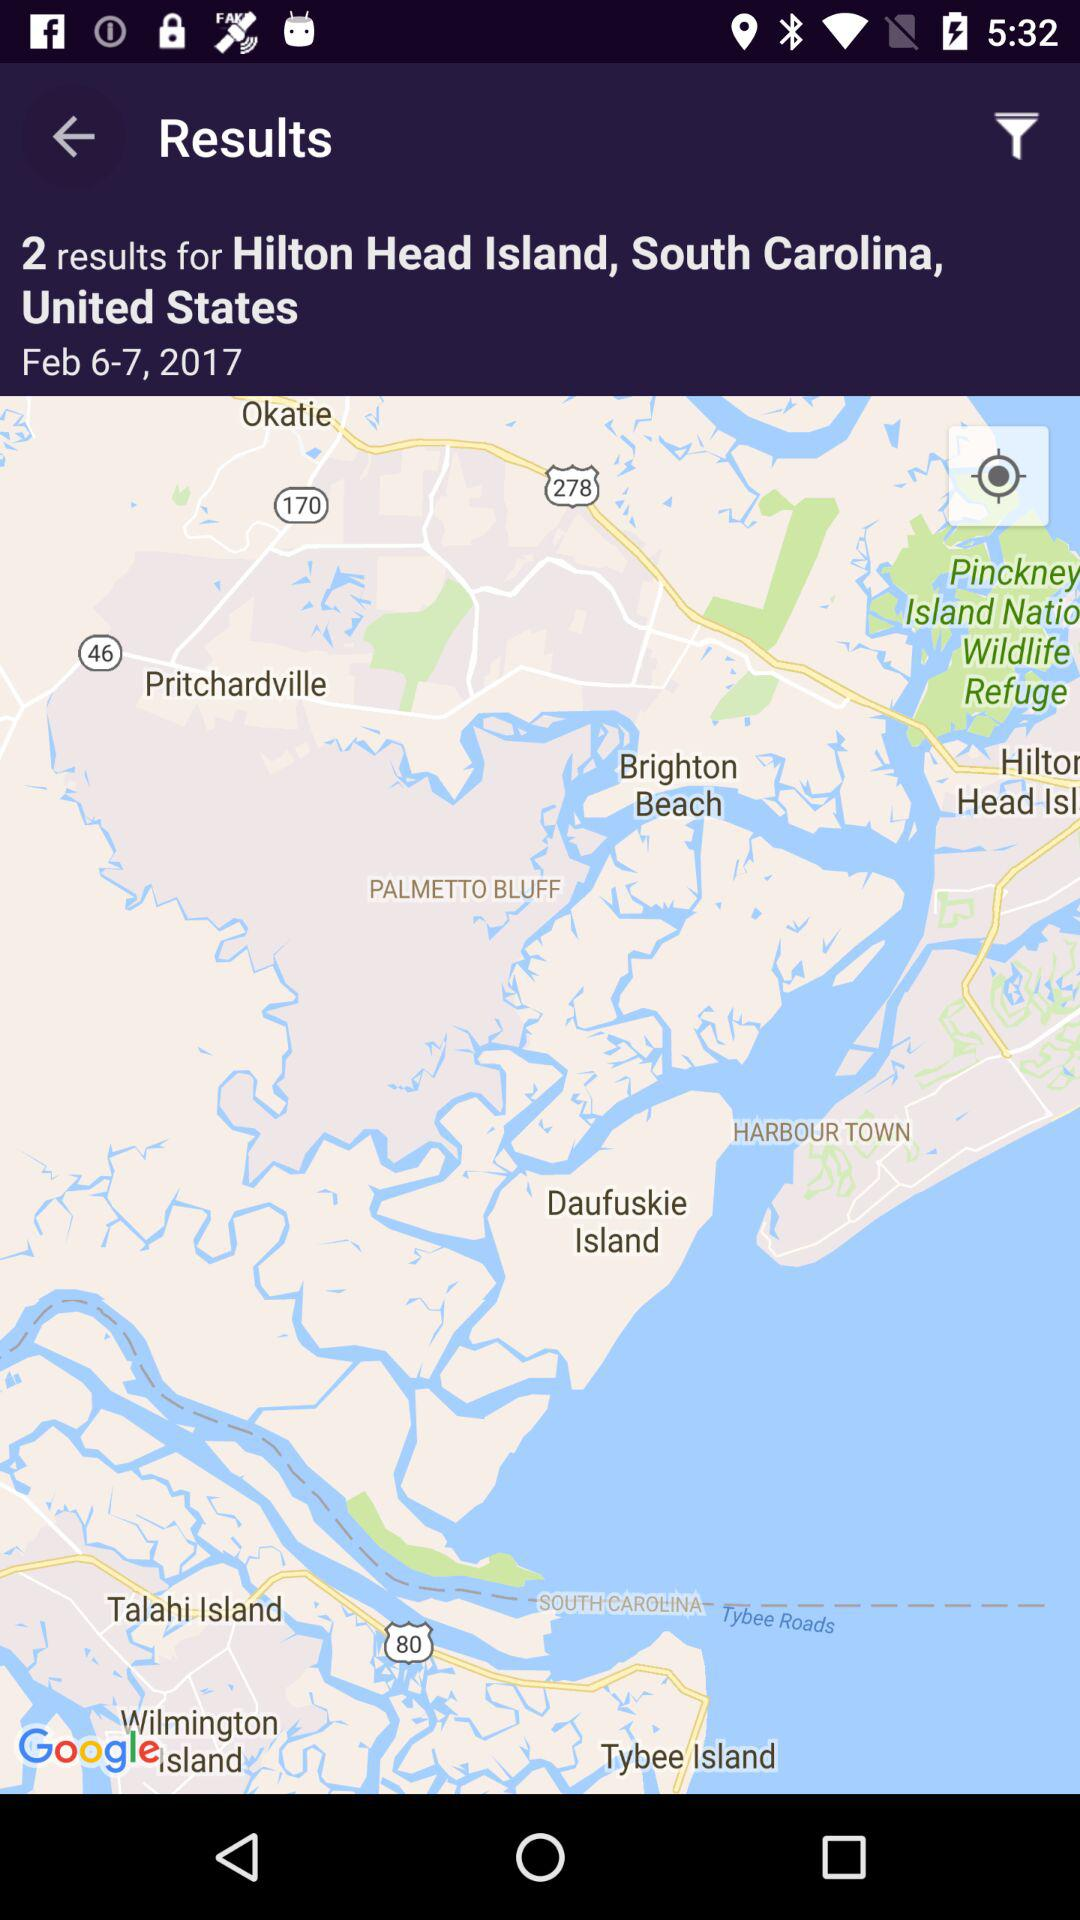How many days are in the search results?
Answer the question using a single word or phrase. 2 